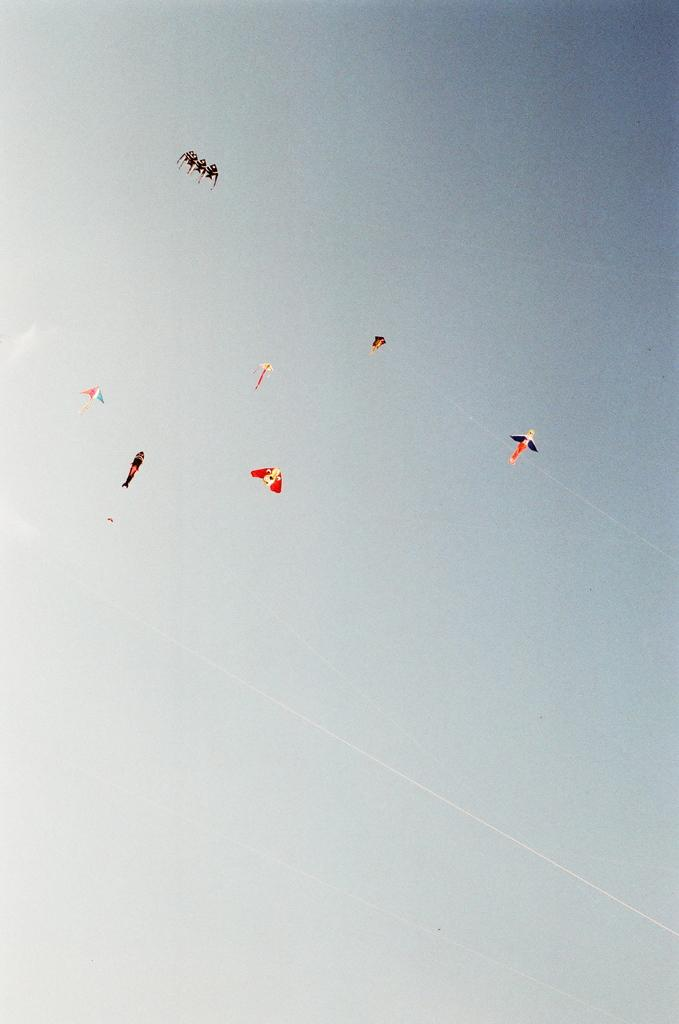What is happening in the sky in the image? Kites are flying in the sky in the image. Can you describe the activity taking place in the sky? The activity in the sky involves kites being flown. How many bubbles can be seen floating in the sky in the image? There are no bubbles present in the image; it features kites flying in the sky. What type of dog is visible in the image? There is no dog present in the image; it features kites flying in the sky. 